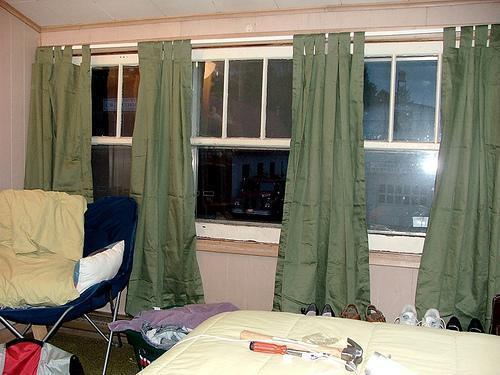What time of day is it likely to be?
Make your selection from the four choices given to correctly answer the question.
Options: Midday, evening, night, morning. Evening. 